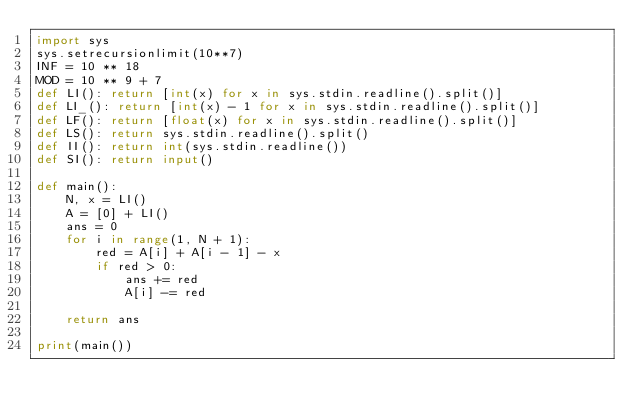Convert code to text. <code><loc_0><loc_0><loc_500><loc_500><_Python_>import sys
sys.setrecursionlimit(10**7)
INF = 10 ** 18
MOD = 10 ** 9 + 7
def LI(): return [int(x) for x in sys.stdin.readline().split()]
def LI_(): return [int(x) - 1 for x in sys.stdin.readline().split()]
def LF(): return [float(x) for x in sys.stdin.readline().split()]
def LS(): return sys.stdin.readline().split()
def II(): return int(sys.stdin.readline())
def SI(): return input()

def main():
    N, x = LI()
    A = [0] + LI()
    ans = 0
    for i in range(1, N + 1):
        red = A[i] + A[i - 1] - x
        if red > 0:
            ans += red
            A[i] -= red

    return ans

print(main())</code> 